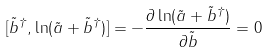Convert formula to latex. <formula><loc_0><loc_0><loc_500><loc_500>[ \tilde { b } ^ { \dag } , \ln ( \tilde { a } + \tilde { b } ^ { \dag } ) ] = - \frac { \partial \ln ( \tilde { a } + \tilde { b } ^ { \dag } ) } { \partial \tilde { b } } = 0</formula> 